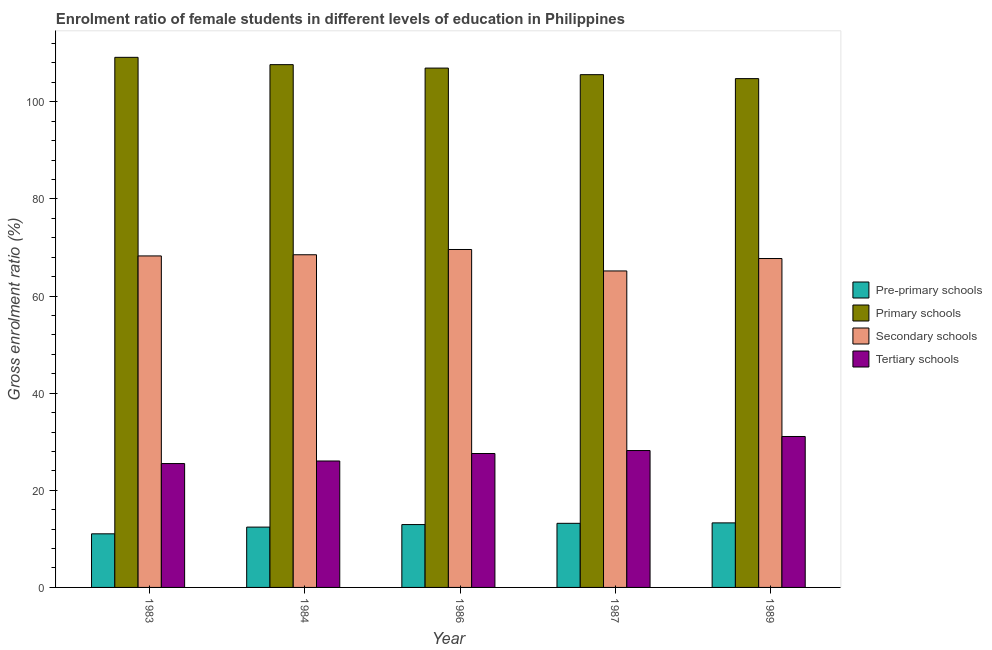How many different coloured bars are there?
Your response must be concise. 4. Are the number of bars per tick equal to the number of legend labels?
Provide a succinct answer. Yes. Are the number of bars on each tick of the X-axis equal?
Offer a terse response. Yes. How many bars are there on the 5th tick from the left?
Offer a terse response. 4. What is the label of the 4th group of bars from the left?
Make the answer very short. 1987. In how many cases, is the number of bars for a given year not equal to the number of legend labels?
Offer a terse response. 0. What is the gross enrolment ratio(male) in primary schools in 1984?
Your answer should be compact. 107.64. Across all years, what is the maximum gross enrolment ratio(male) in pre-primary schools?
Your response must be concise. 13.29. Across all years, what is the minimum gross enrolment ratio(male) in primary schools?
Keep it short and to the point. 104.76. In which year was the gross enrolment ratio(male) in secondary schools maximum?
Your answer should be compact. 1986. In which year was the gross enrolment ratio(male) in tertiary schools minimum?
Your answer should be compact. 1983. What is the total gross enrolment ratio(male) in secondary schools in the graph?
Your answer should be very brief. 339.21. What is the difference between the gross enrolment ratio(male) in pre-primary schools in 1984 and that in 1989?
Provide a succinct answer. -0.87. What is the difference between the gross enrolment ratio(male) in pre-primary schools in 1989 and the gross enrolment ratio(male) in tertiary schools in 1984?
Provide a short and direct response. 0.87. What is the average gross enrolment ratio(male) in primary schools per year?
Make the answer very short. 106.81. In how many years, is the gross enrolment ratio(male) in tertiary schools greater than 60 %?
Your answer should be compact. 0. What is the ratio of the gross enrolment ratio(male) in pre-primary schools in 1983 to that in 1989?
Provide a short and direct response. 0.83. Is the gross enrolment ratio(male) in tertiary schools in 1983 less than that in 1986?
Give a very brief answer. Yes. What is the difference between the highest and the second highest gross enrolment ratio(male) in secondary schools?
Ensure brevity in your answer.  1.09. What is the difference between the highest and the lowest gross enrolment ratio(male) in pre-primary schools?
Give a very brief answer. 2.25. In how many years, is the gross enrolment ratio(male) in primary schools greater than the average gross enrolment ratio(male) in primary schools taken over all years?
Make the answer very short. 3. Is the sum of the gross enrolment ratio(male) in secondary schools in 1984 and 1986 greater than the maximum gross enrolment ratio(male) in pre-primary schools across all years?
Make the answer very short. Yes. Is it the case that in every year, the sum of the gross enrolment ratio(male) in primary schools and gross enrolment ratio(male) in pre-primary schools is greater than the sum of gross enrolment ratio(male) in secondary schools and gross enrolment ratio(male) in tertiary schools?
Provide a short and direct response. No. What does the 2nd bar from the left in 1989 represents?
Keep it short and to the point. Primary schools. What does the 3rd bar from the right in 1987 represents?
Provide a short and direct response. Primary schools. Are all the bars in the graph horizontal?
Provide a succinct answer. No. How many years are there in the graph?
Offer a very short reply. 5. What is the difference between two consecutive major ticks on the Y-axis?
Ensure brevity in your answer.  20. Are the values on the major ticks of Y-axis written in scientific E-notation?
Offer a terse response. No. Does the graph contain grids?
Your response must be concise. No. What is the title of the graph?
Your response must be concise. Enrolment ratio of female students in different levels of education in Philippines. What is the label or title of the Y-axis?
Ensure brevity in your answer.  Gross enrolment ratio (%). What is the Gross enrolment ratio (%) in Pre-primary schools in 1983?
Keep it short and to the point. 11.04. What is the Gross enrolment ratio (%) in Primary schools in 1983?
Offer a very short reply. 109.14. What is the Gross enrolment ratio (%) in Secondary schools in 1983?
Your response must be concise. 68.25. What is the Gross enrolment ratio (%) of Tertiary schools in 1983?
Give a very brief answer. 25.5. What is the Gross enrolment ratio (%) in Pre-primary schools in 1984?
Ensure brevity in your answer.  12.42. What is the Gross enrolment ratio (%) in Primary schools in 1984?
Keep it short and to the point. 107.64. What is the Gross enrolment ratio (%) in Secondary schools in 1984?
Ensure brevity in your answer.  68.49. What is the Gross enrolment ratio (%) in Tertiary schools in 1984?
Provide a succinct answer. 26.03. What is the Gross enrolment ratio (%) of Pre-primary schools in 1986?
Offer a very short reply. 12.94. What is the Gross enrolment ratio (%) in Primary schools in 1986?
Make the answer very short. 106.93. What is the Gross enrolment ratio (%) of Secondary schools in 1986?
Your answer should be very brief. 69.58. What is the Gross enrolment ratio (%) in Tertiary schools in 1986?
Offer a terse response. 27.57. What is the Gross enrolment ratio (%) in Pre-primary schools in 1987?
Your answer should be very brief. 13.2. What is the Gross enrolment ratio (%) in Primary schools in 1987?
Your answer should be very brief. 105.57. What is the Gross enrolment ratio (%) in Secondary schools in 1987?
Keep it short and to the point. 65.16. What is the Gross enrolment ratio (%) of Tertiary schools in 1987?
Your answer should be very brief. 28.18. What is the Gross enrolment ratio (%) of Pre-primary schools in 1989?
Your response must be concise. 13.29. What is the Gross enrolment ratio (%) of Primary schools in 1989?
Offer a terse response. 104.76. What is the Gross enrolment ratio (%) in Secondary schools in 1989?
Ensure brevity in your answer.  67.72. What is the Gross enrolment ratio (%) of Tertiary schools in 1989?
Your response must be concise. 31.08. Across all years, what is the maximum Gross enrolment ratio (%) in Pre-primary schools?
Provide a short and direct response. 13.29. Across all years, what is the maximum Gross enrolment ratio (%) of Primary schools?
Your answer should be compact. 109.14. Across all years, what is the maximum Gross enrolment ratio (%) in Secondary schools?
Offer a terse response. 69.58. Across all years, what is the maximum Gross enrolment ratio (%) in Tertiary schools?
Offer a terse response. 31.08. Across all years, what is the minimum Gross enrolment ratio (%) of Pre-primary schools?
Offer a very short reply. 11.04. Across all years, what is the minimum Gross enrolment ratio (%) in Primary schools?
Ensure brevity in your answer.  104.76. Across all years, what is the minimum Gross enrolment ratio (%) in Secondary schools?
Offer a terse response. 65.16. Across all years, what is the minimum Gross enrolment ratio (%) in Tertiary schools?
Your answer should be compact. 25.5. What is the total Gross enrolment ratio (%) in Pre-primary schools in the graph?
Your response must be concise. 62.89. What is the total Gross enrolment ratio (%) of Primary schools in the graph?
Your response must be concise. 534.04. What is the total Gross enrolment ratio (%) in Secondary schools in the graph?
Ensure brevity in your answer.  339.21. What is the total Gross enrolment ratio (%) in Tertiary schools in the graph?
Your answer should be compact. 138.37. What is the difference between the Gross enrolment ratio (%) of Pre-primary schools in 1983 and that in 1984?
Provide a succinct answer. -1.38. What is the difference between the Gross enrolment ratio (%) in Primary schools in 1983 and that in 1984?
Give a very brief answer. 1.51. What is the difference between the Gross enrolment ratio (%) of Secondary schools in 1983 and that in 1984?
Offer a very short reply. -0.24. What is the difference between the Gross enrolment ratio (%) of Tertiary schools in 1983 and that in 1984?
Offer a very short reply. -0.53. What is the difference between the Gross enrolment ratio (%) in Pre-primary schools in 1983 and that in 1986?
Your answer should be compact. -1.9. What is the difference between the Gross enrolment ratio (%) of Primary schools in 1983 and that in 1986?
Your answer should be compact. 2.21. What is the difference between the Gross enrolment ratio (%) in Secondary schools in 1983 and that in 1986?
Make the answer very short. -1.33. What is the difference between the Gross enrolment ratio (%) in Tertiary schools in 1983 and that in 1986?
Your answer should be very brief. -2.07. What is the difference between the Gross enrolment ratio (%) of Pre-primary schools in 1983 and that in 1987?
Provide a short and direct response. -2.16. What is the difference between the Gross enrolment ratio (%) in Primary schools in 1983 and that in 1987?
Give a very brief answer. 3.57. What is the difference between the Gross enrolment ratio (%) of Secondary schools in 1983 and that in 1987?
Ensure brevity in your answer.  3.09. What is the difference between the Gross enrolment ratio (%) in Tertiary schools in 1983 and that in 1987?
Ensure brevity in your answer.  -2.68. What is the difference between the Gross enrolment ratio (%) in Pre-primary schools in 1983 and that in 1989?
Your response must be concise. -2.25. What is the difference between the Gross enrolment ratio (%) in Primary schools in 1983 and that in 1989?
Your response must be concise. 4.38. What is the difference between the Gross enrolment ratio (%) in Secondary schools in 1983 and that in 1989?
Make the answer very short. 0.54. What is the difference between the Gross enrolment ratio (%) in Tertiary schools in 1983 and that in 1989?
Keep it short and to the point. -5.57. What is the difference between the Gross enrolment ratio (%) in Pre-primary schools in 1984 and that in 1986?
Your answer should be compact. -0.52. What is the difference between the Gross enrolment ratio (%) of Primary schools in 1984 and that in 1986?
Keep it short and to the point. 0.71. What is the difference between the Gross enrolment ratio (%) of Secondary schools in 1984 and that in 1986?
Provide a succinct answer. -1.09. What is the difference between the Gross enrolment ratio (%) of Tertiary schools in 1984 and that in 1986?
Keep it short and to the point. -1.54. What is the difference between the Gross enrolment ratio (%) in Pre-primary schools in 1984 and that in 1987?
Your response must be concise. -0.78. What is the difference between the Gross enrolment ratio (%) of Primary schools in 1984 and that in 1987?
Keep it short and to the point. 2.06. What is the difference between the Gross enrolment ratio (%) in Secondary schools in 1984 and that in 1987?
Make the answer very short. 3.33. What is the difference between the Gross enrolment ratio (%) of Tertiary schools in 1984 and that in 1987?
Provide a succinct answer. -2.15. What is the difference between the Gross enrolment ratio (%) of Pre-primary schools in 1984 and that in 1989?
Keep it short and to the point. -0.87. What is the difference between the Gross enrolment ratio (%) in Primary schools in 1984 and that in 1989?
Your answer should be very brief. 2.88. What is the difference between the Gross enrolment ratio (%) of Secondary schools in 1984 and that in 1989?
Ensure brevity in your answer.  0.78. What is the difference between the Gross enrolment ratio (%) of Tertiary schools in 1984 and that in 1989?
Your response must be concise. -5.04. What is the difference between the Gross enrolment ratio (%) of Pre-primary schools in 1986 and that in 1987?
Make the answer very short. -0.26. What is the difference between the Gross enrolment ratio (%) in Primary schools in 1986 and that in 1987?
Your response must be concise. 1.35. What is the difference between the Gross enrolment ratio (%) of Secondary schools in 1986 and that in 1987?
Your answer should be very brief. 4.42. What is the difference between the Gross enrolment ratio (%) of Tertiary schools in 1986 and that in 1987?
Ensure brevity in your answer.  -0.61. What is the difference between the Gross enrolment ratio (%) in Pre-primary schools in 1986 and that in 1989?
Offer a very short reply. -0.35. What is the difference between the Gross enrolment ratio (%) of Primary schools in 1986 and that in 1989?
Offer a terse response. 2.17. What is the difference between the Gross enrolment ratio (%) of Secondary schools in 1986 and that in 1989?
Offer a terse response. 1.86. What is the difference between the Gross enrolment ratio (%) of Tertiary schools in 1986 and that in 1989?
Your answer should be very brief. -3.51. What is the difference between the Gross enrolment ratio (%) in Pre-primary schools in 1987 and that in 1989?
Make the answer very short. -0.09. What is the difference between the Gross enrolment ratio (%) of Primary schools in 1987 and that in 1989?
Give a very brief answer. 0.82. What is the difference between the Gross enrolment ratio (%) in Secondary schools in 1987 and that in 1989?
Offer a very short reply. -2.56. What is the difference between the Gross enrolment ratio (%) of Tertiary schools in 1987 and that in 1989?
Make the answer very short. -2.89. What is the difference between the Gross enrolment ratio (%) of Pre-primary schools in 1983 and the Gross enrolment ratio (%) of Primary schools in 1984?
Provide a succinct answer. -96.6. What is the difference between the Gross enrolment ratio (%) of Pre-primary schools in 1983 and the Gross enrolment ratio (%) of Secondary schools in 1984?
Provide a succinct answer. -57.46. What is the difference between the Gross enrolment ratio (%) of Pre-primary schools in 1983 and the Gross enrolment ratio (%) of Tertiary schools in 1984?
Offer a terse response. -15. What is the difference between the Gross enrolment ratio (%) in Primary schools in 1983 and the Gross enrolment ratio (%) in Secondary schools in 1984?
Provide a short and direct response. 40.65. What is the difference between the Gross enrolment ratio (%) of Primary schools in 1983 and the Gross enrolment ratio (%) of Tertiary schools in 1984?
Keep it short and to the point. 83.11. What is the difference between the Gross enrolment ratio (%) in Secondary schools in 1983 and the Gross enrolment ratio (%) in Tertiary schools in 1984?
Your answer should be compact. 42.22. What is the difference between the Gross enrolment ratio (%) in Pre-primary schools in 1983 and the Gross enrolment ratio (%) in Primary schools in 1986?
Keep it short and to the point. -95.89. What is the difference between the Gross enrolment ratio (%) in Pre-primary schools in 1983 and the Gross enrolment ratio (%) in Secondary schools in 1986?
Keep it short and to the point. -58.54. What is the difference between the Gross enrolment ratio (%) in Pre-primary schools in 1983 and the Gross enrolment ratio (%) in Tertiary schools in 1986?
Your answer should be compact. -16.54. What is the difference between the Gross enrolment ratio (%) in Primary schools in 1983 and the Gross enrolment ratio (%) in Secondary schools in 1986?
Keep it short and to the point. 39.56. What is the difference between the Gross enrolment ratio (%) in Primary schools in 1983 and the Gross enrolment ratio (%) in Tertiary schools in 1986?
Ensure brevity in your answer.  81.57. What is the difference between the Gross enrolment ratio (%) in Secondary schools in 1983 and the Gross enrolment ratio (%) in Tertiary schools in 1986?
Offer a terse response. 40.68. What is the difference between the Gross enrolment ratio (%) in Pre-primary schools in 1983 and the Gross enrolment ratio (%) in Primary schools in 1987?
Keep it short and to the point. -94.54. What is the difference between the Gross enrolment ratio (%) of Pre-primary schools in 1983 and the Gross enrolment ratio (%) of Secondary schools in 1987?
Give a very brief answer. -54.12. What is the difference between the Gross enrolment ratio (%) of Pre-primary schools in 1983 and the Gross enrolment ratio (%) of Tertiary schools in 1987?
Provide a succinct answer. -17.15. What is the difference between the Gross enrolment ratio (%) in Primary schools in 1983 and the Gross enrolment ratio (%) in Secondary schools in 1987?
Ensure brevity in your answer.  43.98. What is the difference between the Gross enrolment ratio (%) in Primary schools in 1983 and the Gross enrolment ratio (%) in Tertiary schools in 1987?
Offer a terse response. 80.96. What is the difference between the Gross enrolment ratio (%) of Secondary schools in 1983 and the Gross enrolment ratio (%) of Tertiary schools in 1987?
Keep it short and to the point. 40.07. What is the difference between the Gross enrolment ratio (%) of Pre-primary schools in 1983 and the Gross enrolment ratio (%) of Primary schools in 1989?
Your answer should be compact. -93.72. What is the difference between the Gross enrolment ratio (%) of Pre-primary schools in 1983 and the Gross enrolment ratio (%) of Secondary schools in 1989?
Ensure brevity in your answer.  -56.68. What is the difference between the Gross enrolment ratio (%) of Pre-primary schools in 1983 and the Gross enrolment ratio (%) of Tertiary schools in 1989?
Provide a short and direct response. -20.04. What is the difference between the Gross enrolment ratio (%) of Primary schools in 1983 and the Gross enrolment ratio (%) of Secondary schools in 1989?
Offer a terse response. 41.43. What is the difference between the Gross enrolment ratio (%) of Primary schools in 1983 and the Gross enrolment ratio (%) of Tertiary schools in 1989?
Provide a succinct answer. 78.07. What is the difference between the Gross enrolment ratio (%) of Secondary schools in 1983 and the Gross enrolment ratio (%) of Tertiary schools in 1989?
Your answer should be very brief. 37.18. What is the difference between the Gross enrolment ratio (%) in Pre-primary schools in 1984 and the Gross enrolment ratio (%) in Primary schools in 1986?
Ensure brevity in your answer.  -94.51. What is the difference between the Gross enrolment ratio (%) of Pre-primary schools in 1984 and the Gross enrolment ratio (%) of Secondary schools in 1986?
Your answer should be compact. -57.16. What is the difference between the Gross enrolment ratio (%) in Pre-primary schools in 1984 and the Gross enrolment ratio (%) in Tertiary schools in 1986?
Offer a terse response. -15.15. What is the difference between the Gross enrolment ratio (%) in Primary schools in 1984 and the Gross enrolment ratio (%) in Secondary schools in 1986?
Your answer should be compact. 38.06. What is the difference between the Gross enrolment ratio (%) in Primary schools in 1984 and the Gross enrolment ratio (%) in Tertiary schools in 1986?
Provide a succinct answer. 80.06. What is the difference between the Gross enrolment ratio (%) of Secondary schools in 1984 and the Gross enrolment ratio (%) of Tertiary schools in 1986?
Give a very brief answer. 40.92. What is the difference between the Gross enrolment ratio (%) of Pre-primary schools in 1984 and the Gross enrolment ratio (%) of Primary schools in 1987?
Provide a succinct answer. -93.15. What is the difference between the Gross enrolment ratio (%) in Pre-primary schools in 1984 and the Gross enrolment ratio (%) in Secondary schools in 1987?
Offer a very short reply. -52.74. What is the difference between the Gross enrolment ratio (%) in Pre-primary schools in 1984 and the Gross enrolment ratio (%) in Tertiary schools in 1987?
Offer a very short reply. -15.76. What is the difference between the Gross enrolment ratio (%) in Primary schools in 1984 and the Gross enrolment ratio (%) in Secondary schools in 1987?
Your answer should be compact. 42.48. What is the difference between the Gross enrolment ratio (%) in Primary schools in 1984 and the Gross enrolment ratio (%) in Tertiary schools in 1987?
Provide a succinct answer. 79.45. What is the difference between the Gross enrolment ratio (%) of Secondary schools in 1984 and the Gross enrolment ratio (%) of Tertiary schools in 1987?
Your response must be concise. 40.31. What is the difference between the Gross enrolment ratio (%) in Pre-primary schools in 1984 and the Gross enrolment ratio (%) in Primary schools in 1989?
Keep it short and to the point. -92.34. What is the difference between the Gross enrolment ratio (%) in Pre-primary schools in 1984 and the Gross enrolment ratio (%) in Secondary schools in 1989?
Your response must be concise. -55.3. What is the difference between the Gross enrolment ratio (%) in Pre-primary schools in 1984 and the Gross enrolment ratio (%) in Tertiary schools in 1989?
Provide a short and direct response. -18.66. What is the difference between the Gross enrolment ratio (%) in Primary schools in 1984 and the Gross enrolment ratio (%) in Secondary schools in 1989?
Your response must be concise. 39.92. What is the difference between the Gross enrolment ratio (%) of Primary schools in 1984 and the Gross enrolment ratio (%) of Tertiary schools in 1989?
Give a very brief answer. 76.56. What is the difference between the Gross enrolment ratio (%) in Secondary schools in 1984 and the Gross enrolment ratio (%) in Tertiary schools in 1989?
Your answer should be compact. 37.42. What is the difference between the Gross enrolment ratio (%) in Pre-primary schools in 1986 and the Gross enrolment ratio (%) in Primary schools in 1987?
Provide a short and direct response. -92.63. What is the difference between the Gross enrolment ratio (%) of Pre-primary schools in 1986 and the Gross enrolment ratio (%) of Secondary schools in 1987?
Give a very brief answer. -52.22. What is the difference between the Gross enrolment ratio (%) of Pre-primary schools in 1986 and the Gross enrolment ratio (%) of Tertiary schools in 1987?
Provide a succinct answer. -15.24. What is the difference between the Gross enrolment ratio (%) of Primary schools in 1986 and the Gross enrolment ratio (%) of Secondary schools in 1987?
Give a very brief answer. 41.77. What is the difference between the Gross enrolment ratio (%) of Primary schools in 1986 and the Gross enrolment ratio (%) of Tertiary schools in 1987?
Offer a very short reply. 78.75. What is the difference between the Gross enrolment ratio (%) in Secondary schools in 1986 and the Gross enrolment ratio (%) in Tertiary schools in 1987?
Provide a succinct answer. 41.4. What is the difference between the Gross enrolment ratio (%) in Pre-primary schools in 1986 and the Gross enrolment ratio (%) in Primary schools in 1989?
Offer a very short reply. -91.82. What is the difference between the Gross enrolment ratio (%) of Pre-primary schools in 1986 and the Gross enrolment ratio (%) of Secondary schools in 1989?
Your answer should be very brief. -54.78. What is the difference between the Gross enrolment ratio (%) in Pre-primary schools in 1986 and the Gross enrolment ratio (%) in Tertiary schools in 1989?
Give a very brief answer. -18.14. What is the difference between the Gross enrolment ratio (%) of Primary schools in 1986 and the Gross enrolment ratio (%) of Secondary schools in 1989?
Ensure brevity in your answer.  39.21. What is the difference between the Gross enrolment ratio (%) of Primary schools in 1986 and the Gross enrolment ratio (%) of Tertiary schools in 1989?
Give a very brief answer. 75.85. What is the difference between the Gross enrolment ratio (%) in Secondary schools in 1986 and the Gross enrolment ratio (%) in Tertiary schools in 1989?
Your answer should be compact. 38.5. What is the difference between the Gross enrolment ratio (%) of Pre-primary schools in 1987 and the Gross enrolment ratio (%) of Primary schools in 1989?
Your answer should be very brief. -91.56. What is the difference between the Gross enrolment ratio (%) in Pre-primary schools in 1987 and the Gross enrolment ratio (%) in Secondary schools in 1989?
Give a very brief answer. -54.52. What is the difference between the Gross enrolment ratio (%) in Pre-primary schools in 1987 and the Gross enrolment ratio (%) in Tertiary schools in 1989?
Your response must be concise. -17.88. What is the difference between the Gross enrolment ratio (%) in Primary schools in 1987 and the Gross enrolment ratio (%) in Secondary schools in 1989?
Provide a short and direct response. 37.86. What is the difference between the Gross enrolment ratio (%) in Primary schools in 1987 and the Gross enrolment ratio (%) in Tertiary schools in 1989?
Your response must be concise. 74.5. What is the difference between the Gross enrolment ratio (%) in Secondary schools in 1987 and the Gross enrolment ratio (%) in Tertiary schools in 1989?
Offer a very short reply. 34.08. What is the average Gross enrolment ratio (%) in Pre-primary schools per year?
Provide a succinct answer. 12.58. What is the average Gross enrolment ratio (%) of Primary schools per year?
Offer a terse response. 106.81. What is the average Gross enrolment ratio (%) of Secondary schools per year?
Provide a short and direct response. 67.84. What is the average Gross enrolment ratio (%) of Tertiary schools per year?
Provide a short and direct response. 27.67. In the year 1983, what is the difference between the Gross enrolment ratio (%) in Pre-primary schools and Gross enrolment ratio (%) in Primary schools?
Give a very brief answer. -98.11. In the year 1983, what is the difference between the Gross enrolment ratio (%) in Pre-primary schools and Gross enrolment ratio (%) in Secondary schools?
Your response must be concise. -57.22. In the year 1983, what is the difference between the Gross enrolment ratio (%) of Pre-primary schools and Gross enrolment ratio (%) of Tertiary schools?
Offer a very short reply. -14.47. In the year 1983, what is the difference between the Gross enrolment ratio (%) in Primary schools and Gross enrolment ratio (%) in Secondary schools?
Offer a very short reply. 40.89. In the year 1983, what is the difference between the Gross enrolment ratio (%) in Primary schools and Gross enrolment ratio (%) in Tertiary schools?
Your answer should be compact. 83.64. In the year 1983, what is the difference between the Gross enrolment ratio (%) in Secondary schools and Gross enrolment ratio (%) in Tertiary schools?
Keep it short and to the point. 42.75. In the year 1984, what is the difference between the Gross enrolment ratio (%) in Pre-primary schools and Gross enrolment ratio (%) in Primary schools?
Give a very brief answer. -95.22. In the year 1984, what is the difference between the Gross enrolment ratio (%) in Pre-primary schools and Gross enrolment ratio (%) in Secondary schools?
Offer a very short reply. -56.07. In the year 1984, what is the difference between the Gross enrolment ratio (%) in Pre-primary schools and Gross enrolment ratio (%) in Tertiary schools?
Make the answer very short. -13.61. In the year 1984, what is the difference between the Gross enrolment ratio (%) of Primary schools and Gross enrolment ratio (%) of Secondary schools?
Offer a terse response. 39.14. In the year 1984, what is the difference between the Gross enrolment ratio (%) in Primary schools and Gross enrolment ratio (%) in Tertiary schools?
Your answer should be very brief. 81.6. In the year 1984, what is the difference between the Gross enrolment ratio (%) in Secondary schools and Gross enrolment ratio (%) in Tertiary schools?
Make the answer very short. 42.46. In the year 1986, what is the difference between the Gross enrolment ratio (%) in Pre-primary schools and Gross enrolment ratio (%) in Primary schools?
Offer a terse response. -93.99. In the year 1986, what is the difference between the Gross enrolment ratio (%) of Pre-primary schools and Gross enrolment ratio (%) of Secondary schools?
Offer a very short reply. -56.64. In the year 1986, what is the difference between the Gross enrolment ratio (%) in Pre-primary schools and Gross enrolment ratio (%) in Tertiary schools?
Provide a short and direct response. -14.63. In the year 1986, what is the difference between the Gross enrolment ratio (%) in Primary schools and Gross enrolment ratio (%) in Secondary schools?
Make the answer very short. 37.35. In the year 1986, what is the difference between the Gross enrolment ratio (%) in Primary schools and Gross enrolment ratio (%) in Tertiary schools?
Make the answer very short. 79.36. In the year 1986, what is the difference between the Gross enrolment ratio (%) of Secondary schools and Gross enrolment ratio (%) of Tertiary schools?
Give a very brief answer. 42.01. In the year 1987, what is the difference between the Gross enrolment ratio (%) in Pre-primary schools and Gross enrolment ratio (%) in Primary schools?
Provide a succinct answer. -92.38. In the year 1987, what is the difference between the Gross enrolment ratio (%) in Pre-primary schools and Gross enrolment ratio (%) in Secondary schools?
Offer a terse response. -51.96. In the year 1987, what is the difference between the Gross enrolment ratio (%) of Pre-primary schools and Gross enrolment ratio (%) of Tertiary schools?
Provide a succinct answer. -14.99. In the year 1987, what is the difference between the Gross enrolment ratio (%) in Primary schools and Gross enrolment ratio (%) in Secondary schools?
Offer a terse response. 40.41. In the year 1987, what is the difference between the Gross enrolment ratio (%) of Primary schools and Gross enrolment ratio (%) of Tertiary schools?
Your answer should be very brief. 77.39. In the year 1987, what is the difference between the Gross enrolment ratio (%) in Secondary schools and Gross enrolment ratio (%) in Tertiary schools?
Your answer should be compact. 36.98. In the year 1989, what is the difference between the Gross enrolment ratio (%) of Pre-primary schools and Gross enrolment ratio (%) of Primary schools?
Offer a terse response. -91.47. In the year 1989, what is the difference between the Gross enrolment ratio (%) in Pre-primary schools and Gross enrolment ratio (%) in Secondary schools?
Provide a succinct answer. -54.43. In the year 1989, what is the difference between the Gross enrolment ratio (%) in Pre-primary schools and Gross enrolment ratio (%) in Tertiary schools?
Your answer should be very brief. -17.79. In the year 1989, what is the difference between the Gross enrolment ratio (%) in Primary schools and Gross enrolment ratio (%) in Secondary schools?
Your answer should be very brief. 37.04. In the year 1989, what is the difference between the Gross enrolment ratio (%) in Primary schools and Gross enrolment ratio (%) in Tertiary schools?
Provide a succinct answer. 73.68. In the year 1989, what is the difference between the Gross enrolment ratio (%) in Secondary schools and Gross enrolment ratio (%) in Tertiary schools?
Give a very brief answer. 36.64. What is the ratio of the Gross enrolment ratio (%) of Pre-primary schools in 1983 to that in 1984?
Your response must be concise. 0.89. What is the ratio of the Gross enrolment ratio (%) of Secondary schools in 1983 to that in 1984?
Offer a very short reply. 1. What is the ratio of the Gross enrolment ratio (%) of Tertiary schools in 1983 to that in 1984?
Make the answer very short. 0.98. What is the ratio of the Gross enrolment ratio (%) in Pre-primary schools in 1983 to that in 1986?
Your answer should be very brief. 0.85. What is the ratio of the Gross enrolment ratio (%) of Primary schools in 1983 to that in 1986?
Provide a short and direct response. 1.02. What is the ratio of the Gross enrolment ratio (%) of Secondary schools in 1983 to that in 1986?
Keep it short and to the point. 0.98. What is the ratio of the Gross enrolment ratio (%) of Tertiary schools in 1983 to that in 1986?
Make the answer very short. 0.93. What is the ratio of the Gross enrolment ratio (%) of Pre-primary schools in 1983 to that in 1987?
Offer a terse response. 0.84. What is the ratio of the Gross enrolment ratio (%) in Primary schools in 1983 to that in 1987?
Provide a succinct answer. 1.03. What is the ratio of the Gross enrolment ratio (%) of Secondary schools in 1983 to that in 1987?
Provide a short and direct response. 1.05. What is the ratio of the Gross enrolment ratio (%) in Tertiary schools in 1983 to that in 1987?
Offer a very short reply. 0.9. What is the ratio of the Gross enrolment ratio (%) in Pre-primary schools in 1983 to that in 1989?
Provide a short and direct response. 0.83. What is the ratio of the Gross enrolment ratio (%) of Primary schools in 1983 to that in 1989?
Provide a succinct answer. 1.04. What is the ratio of the Gross enrolment ratio (%) of Secondary schools in 1983 to that in 1989?
Your answer should be very brief. 1.01. What is the ratio of the Gross enrolment ratio (%) of Tertiary schools in 1983 to that in 1989?
Provide a succinct answer. 0.82. What is the ratio of the Gross enrolment ratio (%) of Pre-primary schools in 1984 to that in 1986?
Your answer should be very brief. 0.96. What is the ratio of the Gross enrolment ratio (%) of Primary schools in 1984 to that in 1986?
Give a very brief answer. 1.01. What is the ratio of the Gross enrolment ratio (%) in Secondary schools in 1984 to that in 1986?
Your answer should be very brief. 0.98. What is the ratio of the Gross enrolment ratio (%) in Tertiary schools in 1984 to that in 1986?
Give a very brief answer. 0.94. What is the ratio of the Gross enrolment ratio (%) of Pre-primary schools in 1984 to that in 1987?
Offer a very short reply. 0.94. What is the ratio of the Gross enrolment ratio (%) of Primary schools in 1984 to that in 1987?
Make the answer very short. 1.02. What is the ratio of the Gross enrolment ratio (%) of Secondary schools in 1984 to that in 1987?
Offer a very short reply. 1.05. What is the ratio of the Gross enrolment ratio (%) of Tertiary schools in 1984 to that in 1987?
Your answer should be compact. 0.92. What is the ratio of the Gross enrolment ratio (%) in Pre-primary schools in 1984 to that in 1989?
Make the answer very short. 0.93. What is the ratio of the Gross enrolment ratio (%) of Primary schools in 1984 to that in 1989?
Keep it short and to the point. 1.03. What is the ratio of the Gross enrolment ratio (%) of Secondary schools in 1984 to that in 1989?
Your answer should be compact. 1.01. What is the ratio of the Gross enrolment ratio (%) of Tertiary schools in 1984 to that in 1989?
Make the answer very short. 0.84. What is the ratio of the Gross enrolment ratio (%) in Pre-primary schools in 1986 to that in 1987?
Offer a terse response. 0.98. What is the ratio of the Gross enrolment ratio (%) in Primary schools in 1986 to that in 1987?
Give a very brief answer. 1.01. What is the ratio of the Gross enrolment ratio (%) in Secondary schools in 1986 to that in 1987?
Your answer should be very brief. 1.07. What is the ratio of the Gross enrolment ratio (%) in Tertiary schools in 1986 to that in 1987?
Give a very brief answer. 0.98. What is the ratio of the Gross enrolment ratio (%) in Pre-primary schools in 1986 to that in 1989?
Your response must be concise. 0.97. What is the ratio of the Gross enrolment ratio (%) in Primary schools in 1986 to that in 1989?
Keep it short and to the point. 1.02. What is the ratio of the Gross enrolment ratio (%) in Secondary schools in 1986 to that in 1989?
Keep it short and to the point. 1.03. What is the ratio of the Gross enrolment ratio (%) in Tertiary schools in 1986 to that in 1989?
Provide a succinct answer. 0.89. What is the ratio of the Gross enrolment ratio (%) of Primary schools in 1987 to that in 1989?
Offer a very short reply. 1.01. What is the ratio of the Gross enrolment ratio (%) in Secondary schools in 1987 to that in 1989?
Your answer should be compact. 0.96. What is the ratio of the Gross enrolment ratio (%) in Tertiary schools in 1987 to that in 1989?
Keep it short and to the point. 0.91. What is the difference between the highest and the second highest Gross enrolment ratio (%) in Pre-primary schools?
Your response must be concise. 0.09. What is the difference between the highest and the second highest Gross enrolment ratio (%) in Primary schools?
Keep it short and to the point. 1.51. What is the difference between the highest and the second highest Gross enrolment ratio (%) of Secondary schools?
Your answer should be compact. 1.09. What is the difference between the highest and the second highest Gross enrolment ratio (%) in Tertiary schools?
Your response must be concise. 2.89. What is the difference between the highest and the lowest Gross enrolment ratio (%) of Pre-primary schools?
Provide a short and direct response. 2.25. What is the difference between the highest and the lowest Gross enrolment ratio (%) of Primary schools?
Your answer should be compact. 4.38. What is the difference between the highest and the lowest Gross enrolment ratio (%) of Secondary schools?
Provide a short and direct response. 4.42. What is the difference between the highest and the lowest Gross enrolment ratio (%) of Tertiary schools?
Provide a short and direct response. 5.57. 